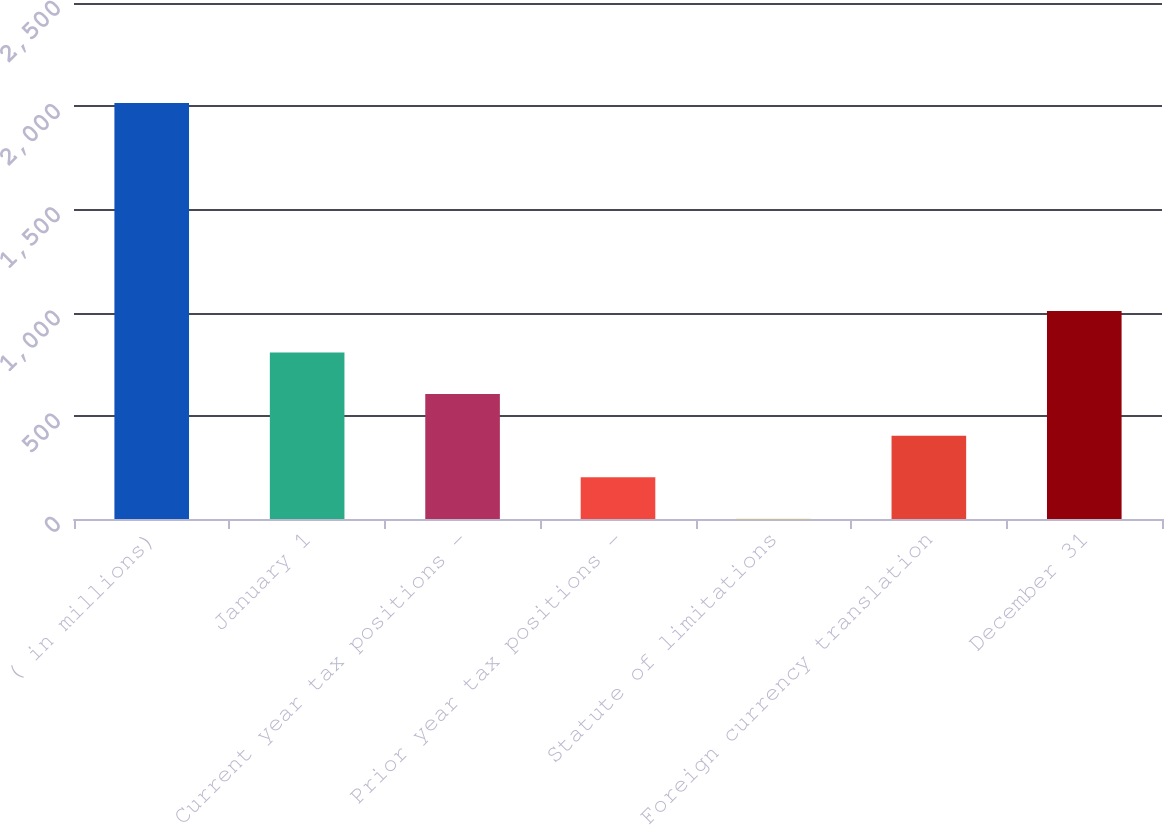Convert chart. <chart><loc_0><loc_0><loc_500><loc_500><bar_chart><fcel>( in millions)<fcel>January 1<fcel>Current year tax positions -<fcel>Prior year tax positions -<fcel>Statute of limitations<fcel>Foreign currency translation<fcel>December 31<nl><fcel>2015<fcel>806.6<fcel>605.2<fcel>202.4<fcel>1<fcel>403.8<fcel>1008<nl></chart> 